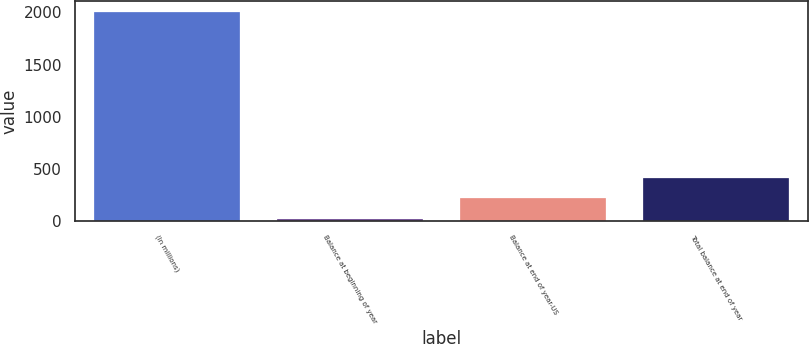<chart> <loc_0><loc_0><loc_500><loc_500><bar_chart><fcel>(In millions)<fcel>Balance at beginning of year<fcel>Balance at end of year-US<fcel>Total balance at end of year<nl><fcel>2008<fcel>18<fcel>217<fcel>416<nl></chart> 